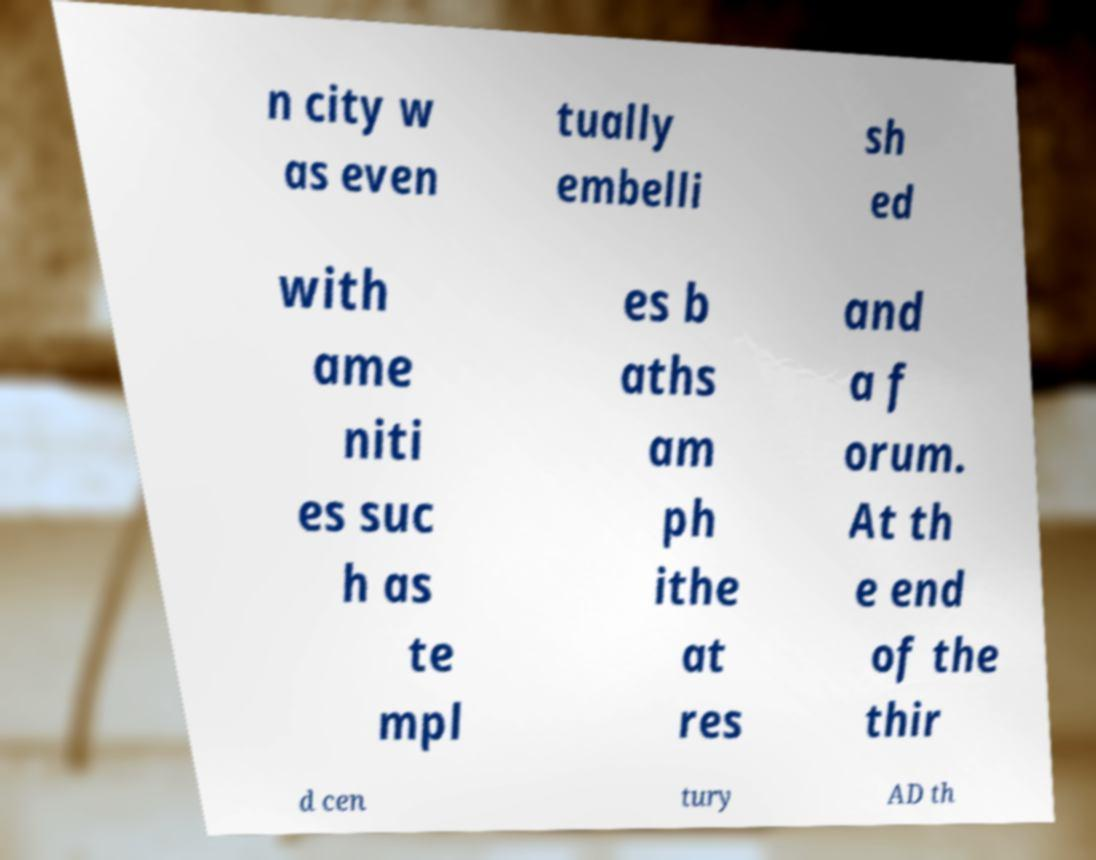Could you extract and type out the text from this image? n city w as even tually embelli sh ed with ame niti es suc h as te mpl es b aths am ph ithe at res and a f orum. At th e end of the thir d cen tury AD th 